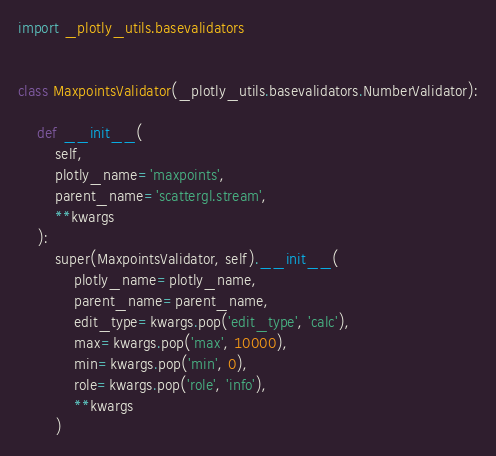Convert code to text. <code><loc_0><loc_0><loc_500><loc_500><_Python_>import _plotly_utils.basevalidators


class MaxpointsValidator(_plotly_utils.basevalidators.NumberValidator):

    def __init__(
        self,
        plotly_name='maxpoints',
        parent_name='scattergl.stream',
        **kwargs
    ):
        super(MaxpointsValidator, self).__init__(
            plotly_name=plotly_name,
            parent_name=parent_name,
            edit_type=kwargs.pop('edit_type', 'calc'),
            max=kwargs.pop('max', 10000),
            min=kwargs.pop('min', 0),
            role=kwargs.pop('role', 'info'),
            **kwargs
        )
</code> 